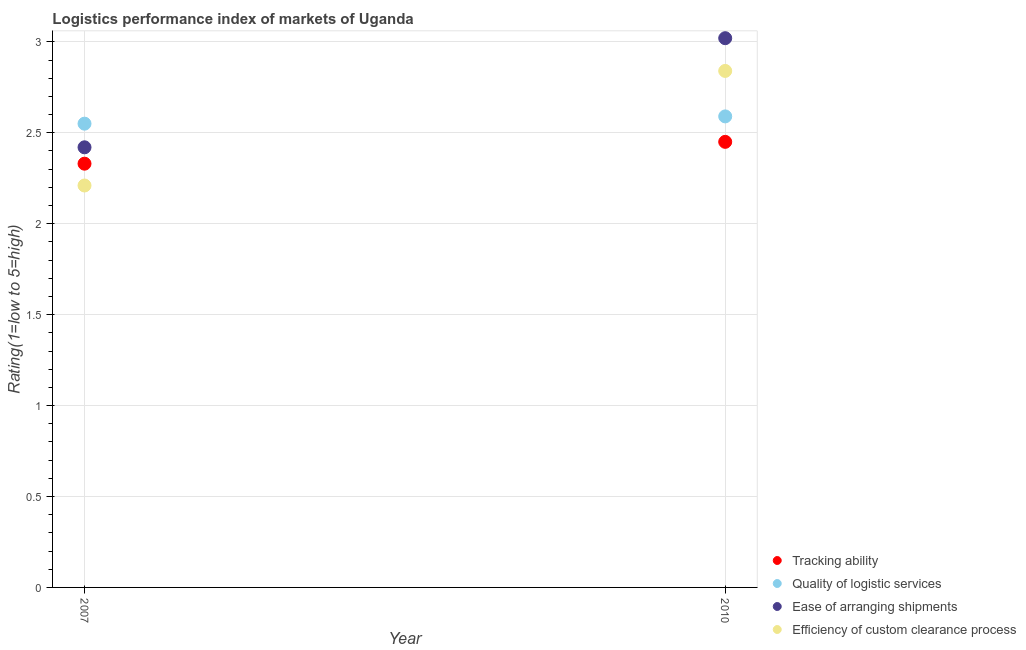What is the lpi rating of quality of logistic services in 2007?
Keep it short and to the point. 2.55. Across all years, what is the maximum lpi rating of tracking ability?
Your response must be concise. 2.45. Across all years, what is the minimum lpi rating of tracking ability?
Your answer should be compact. 2.33. In which year was the lpi rating of tracking ability minimum?
Offer a very short reply. 2007. What is the total lpi rating of efficiency of custom clearance process in the graph?
Provide a short and direct response. 5.05. What is the difference between the lpi rating of tracking ability in 2007 and that in 2010?
Keep it short and to the point. -0.12. What is the difference between the lpi rating of efficiency of custom clearance process in 2007 and the lpi rating of tracking ability in 2010?
Provide a short and direct response. -0.24. What is the average lpi rating of ease of arranging shipments per year?
Provide a short and direct response. 2.72. In the year 2007, what is the difference between the lpi rating of ease of arranging shipments and lpi rating of tracking ability?
Ensure brevity in your answer.  0.09. What is the ratio of the lpi rating of tracking ability in 2007 to that in 2010?
Provide a short and direct response. 0.95. Is the lpi rating of ease of arranging shipments in 2007 less than that in 2010?
Ensure brevity in your answer.  Yes. Is it the case that in every year, the sum of the lpi rating of efficiency of custom clearance process and lpi rating of quality of logistic services is greater than the sum of lpi rating of ease of arranging shipments and lpi rating of tracking ability?
Offer a very short reply. No. Does the lpi rating of ease of arranging shipments monotonically increase over the years?
Offer a very short reply. Yes. Is the lpi rating of tracking ability strictly greater than the lpi rating of efficiency of custom clearance process over the years?
Offer a terse response. No. What is the difference between two consecutive major ticks on the Y-axis?
Your answer should be compact. 0.5. Does the graph contain grids?
Your response must be concise. Yes. Where does the legend appear in the graph?
Ensure brevity in your answer.  Bottom right. How are the legend labels stacked?
Your response must be concise. Vertical. What is the title of the graph?
Your answer should be very brief. Logistics performance index of markets of Uganda. Does "Quality Certification" appear as one of the legend labels in the graph?
Provide a short and direct response. No. What is the label or title of the X-axis?
Your answer should be compact. Year. What is the label or title of the Y-axis?
Ensure brevity in your answer.  Rating(1=low to 5=high). What is the Rating(1=low to 5=high) in Tracking ability in 2007?
Your answer should be very brief. 2.33. What is the Rating(1=low to 5=high) of Quality of logistic services in 2007?
Offer a very short reply. 2.55. What is the Rating(1=low to 5=high) in Ease of arranging shipments in 2007?
Make the answer very short. 2.42. What is the Rating(1=low to 5=high) in Efficiency of custom clearance process in 2007?
Your response must be concise. 2.21. What is the Rating(1=low to 5=high) in Tracking ability in 2010?
Give a very brief answer. 2.45. What is the Rating(1=low to 5=high) of Quality of logistic services in 2010?
Make the answer very short. 2.59. What is the Rating(1=low to 5=high) in Ease of arranging shipments in 2010?
Keep it short and to the point. 3.02. What is the Rating(1=low to 5=high) of Efficiency of custom clearance process in 2010?
Your answer should be very brief. 2.84. Across all years, what is the maximum Rating(1=low to 5=high) in Tracking ability?
Make the answer very short. 2.45. Across all years, what is the maximum Rating(1=low to 5=high) in Quality of logistic services?
Give a very brief answer. 2.59. Across all years, what is the maximum Rating(1=low to 5=high) in Ease of arranging shipments?
Provide a succinct answer. 3.02. Across all years, what is the maximum Rating(1=low to 5=high) in Efficiency of custom clearance process?
Your answer should be very brief. 2.84. Across all years, what is the minimum Rating(1=low to 5=high) of Tracking ability?
Keep it short and to the point. 2.33. Across all years, what is the minimum Rating(1=low to 5=high) of Quality of logistic services?
Your answer should be very brief. 2.55. Across all years, what is the minimum Rating(1=low to 5=high) of Ease of arranging shipments?
Your answer should be very brief. 2.42. Across all years, what is the minimum Rating(1=low to 5=high) of Efficiency of custom clearance process?
Your answer should be compact. 2.21. What is the total Rating(1=low to 5=high) in Tracking ability in the graph?
Ensure brevity in your answer.  4.78. What is the total Rating(1=low to 5=high) of Quality of logistic services in the graph?
Give a very brief answer. 5.14. What is the total Rating(1=low to 5=high) of Ease of arranging shipments in the graph?
Your answer should be compact. 5.44. What is the total Rating(1=low to 5=high) in Efficiency of custom clearance process in the graph?
Make the answer very short. 5.05. What is the difference between the Rating(1=low to 5=high) in Tracking ability in 2007 and that in 2010?
Provide a succinct answer. -0.12. What is the difference between the Rating(1=low to 5=high) of Quality of logistic services in 2007 and that in 2010?
Your answer should be compact. -0.04. What is the difference between the Rating(1=low to 5=high) of Efficiency of custom clearance process in 2007 and that in 2010?
Your answer should be very brief. -0.63. What is the difference between the Rating(1=low to 5=high) of Tracking ability in 2007 and the Rating(1=low to 5=high) of Quality of logistic services in 2010?
Ensure brevity in your answer.  -0.26. What is the difference between the Rating(1=low to 5=high) of Tracking ability in 2007 and the Rating(1=low to 5=high) of Ease of arranging shipments in 2010?
Ensure brevity in your answer.  -0.69. What is the difference between the Rating(1=low to 5=high) in Tracking ability in 2007 and the Rating(1=low to 5=high) in Efficiency of custom clearance process in 2010?
Offer a very short reply. -0.51. What is the difference between the Rating(1=low to 5=high) in Quality of logistic services in 2007 and the Rating(1=low to 5=high) in Ease of arranging shipments in 2010?
Make the answer very short. -0.47. What is the difference between the Rating(1=low to 5=high) of Quality of logistic services in 2007 and the Rating(1=low to 5=high) of Efficiency of custom clearance process in 2010?
Make the answer very short. -0.29. What is the difference between the Rating(1=low to 5=high) in Ease of arranging shipments in 2007 and the Rating(1=low to 5=high) in Efficiency of custom clearance process in 2010?
Ensure brevity in your answer.  -0.42. What is the average Rating(1=low to 5=high) in Tracking ability per year?
Your answer should be compact. 2.39. What is the average Rating(1=low to 5=high) of Quality of logistic services per year?
Offer a very short reply. 2.57. What is the average Rating(1=low to 5=high) of Ease of arranging shipments per year?
Ensure brevity in your answer.  2.72. What is the average Rating(1=low to 5=high) in Efficiency of custom clearance process per year?
Your response must be concise. 2.52. In the year 2007, what is the difference between the Rating(1=low to 5=high) of Tracking ability and Rating(1=low to 5=high) of Quality of logistic services?
Your answer should be very brief. -0.22. In the year 2007, what is the difference between the Rating(1=low to 5=high) of Tracking ability and Rating(1=low to 5=high) of Ease of arranging shipments?
Your answer should be very brief. -0.09. In the year 2007, what is the difference between the Rating(1=low to 5=high) of Tracking ability and Rating(1=low to 5=high) of Efficiency of custom clearance process?
Provide a succinct answer. 0.12. In the year 2007, what is the difference between the Rating(1=low to 5=high) in Quality of logistic services and Rating(1=low to 5=high) in Ease of arranging shipments?
Your answer should be very brief. 0.13. In the year 2007, what is the difference between the Rating(1=low to 5=high) of Quality of logistic services and Rating(1=low to 5=high) of Efficiency of custom clearance process?
Ensure brevity in your answer.  0.34. In the year 2007, what is the difference between the Rating(1=low to 5=high) in Ease of arranging shipments and Rating(1=low to 5=high) in Efficiency of custom clearance process?
Provide a short and direct response. 0.21. In the year 2010, what is the difference between the Rating(1=low to 5=high) in Tracking ability and Rating(1=low to 5=high) in Quality of logistic services?
Make the answer very short. -0.14. In the year 2010, what is the difference between the Rating(1=low to 5=high) in Tracking ability and Rating(1=low to 5=high) in Ease of arranging shipments?
Provide a succinct answer. -0.57. In the year 2010, what is the difference between the Rating(1=low to 5=high) in Tracking ability and Rating(1=low to 5=high) in Efficiency of custom clearance process?
Give a very brief answer. -0.39. In the year 2010, what is the difference between the Rating(1=low to 5=high) of Quality of logistic services and Rating(1=low to 5=high) of Ease of arranging shipments?
Offer a terse response. -0.43. In the year 2010, what is the difference between the Rating(1=low to 5=high) of Quality of logistic services and Rating(1=low to 5=high) of Efficiency of custom clearance process?
Your answer should be compact. -0.25. In the year 2010, what is the difference between the Rating(1=low to 5=high) of Ease of arranging shipments and Rating(1=low to 5=high) of Efficiency of custom clearance process?
Offer a terse response. 0.18. What is the ratio of the Rating(1=low to 5=high) in Tracking ability in 2007 to that in 2010?
Keep it short and to the point. 0.95. What is the ratio of the Rating(1=low to 5=high) of Quality of logistic services in 2007 to that in 2010?
Your answer should be very brief. 0.98. What is the ratio of the Rating(1=low to 5=high) of Ease of arranging shipments in 2007 to that in 2010?
Your answer should be compact. 0.8. What is the ratio of the Rating(1=low to 5=high) in Efficiency of custom clearance process in 2007 to that in 2010?
Provide a short and direct response. 0.78. What is the difference between the highest and the second highest Rating(1=low to 5=high) in Tracking ability?
Provide a succinct answer. 0.12. What is the difference between the highest and the second highest Rating(1=low to 5=high) of Quality of logistic services?
Make the answer very short. 0.04. What is the difference between the highest and the second highest Rating(1=low to 5=high) in Efficiency of custom clearance process?
Make the answer very short. 0.63. What is the difference between the highest and the lowest Rating(1=low to 5=high) in Tracking ability?
Offer a very short reply. 0.12. What is the difference between the highest and the lowest Rating(1=low to 5=high) in Ease of arranging shipments?
Offer a very short reply. 0.6. What is the difference between the highest and the lowest Rating(1=low to 5=high) in Efficiency of custom clearance process?
Offer a terse response. 0.63. 